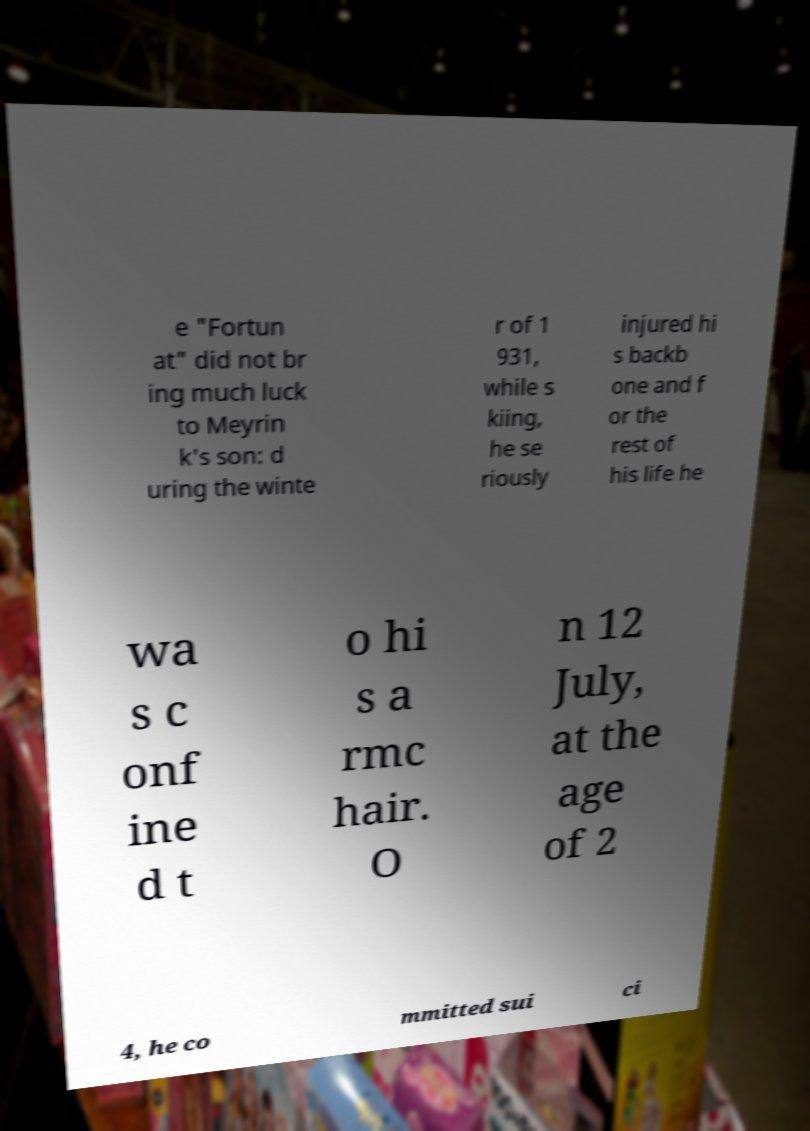For documentation purposes, I need the text within this image transcribed. Could you provide that? e "Fortun at" did not br ing much luck to Meyrin k's son: d uring the winte r of 1 931, while s kiing, he se riously injured hi s backb one and f or the rest of his life he wa s c onf ine d t o hi s a rmc hair. O n 12 July, at the age of 2 4, he co mmitted sui ci 